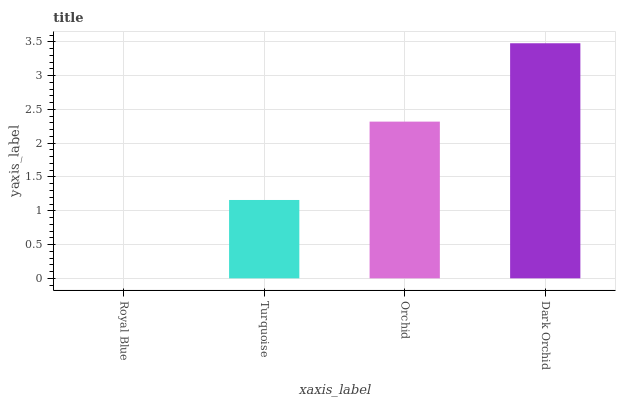Is Royal Blue the minimum?
Answer yes or no. Yes. Is Dark Orchid the maximum?
Answer yes or no. Yes. Is Turquoise the minimum?
Answer yes or no. No. Is Turquoise the maximum?
Answer yes or no. No. Is Turquoise greater than Royal Blue?
Answer yes or no. Yes. Is Royal Blue less than Turquoise?
Answer yes or no. Yes. Is Royal Blue greater than Turquoise?
Answer yes or no. No. Is Turquoise less than Royal Blue?
Answer yes or no. No. Is Orchid the high median?
Answer yes or no. Yes. Is Turquoise the low median?
Answer yes or no. Yes. Is Royal Blue the high median?
Answer yes or no. No. Is Royal Blue the low median?
Answer yes or no. No. 